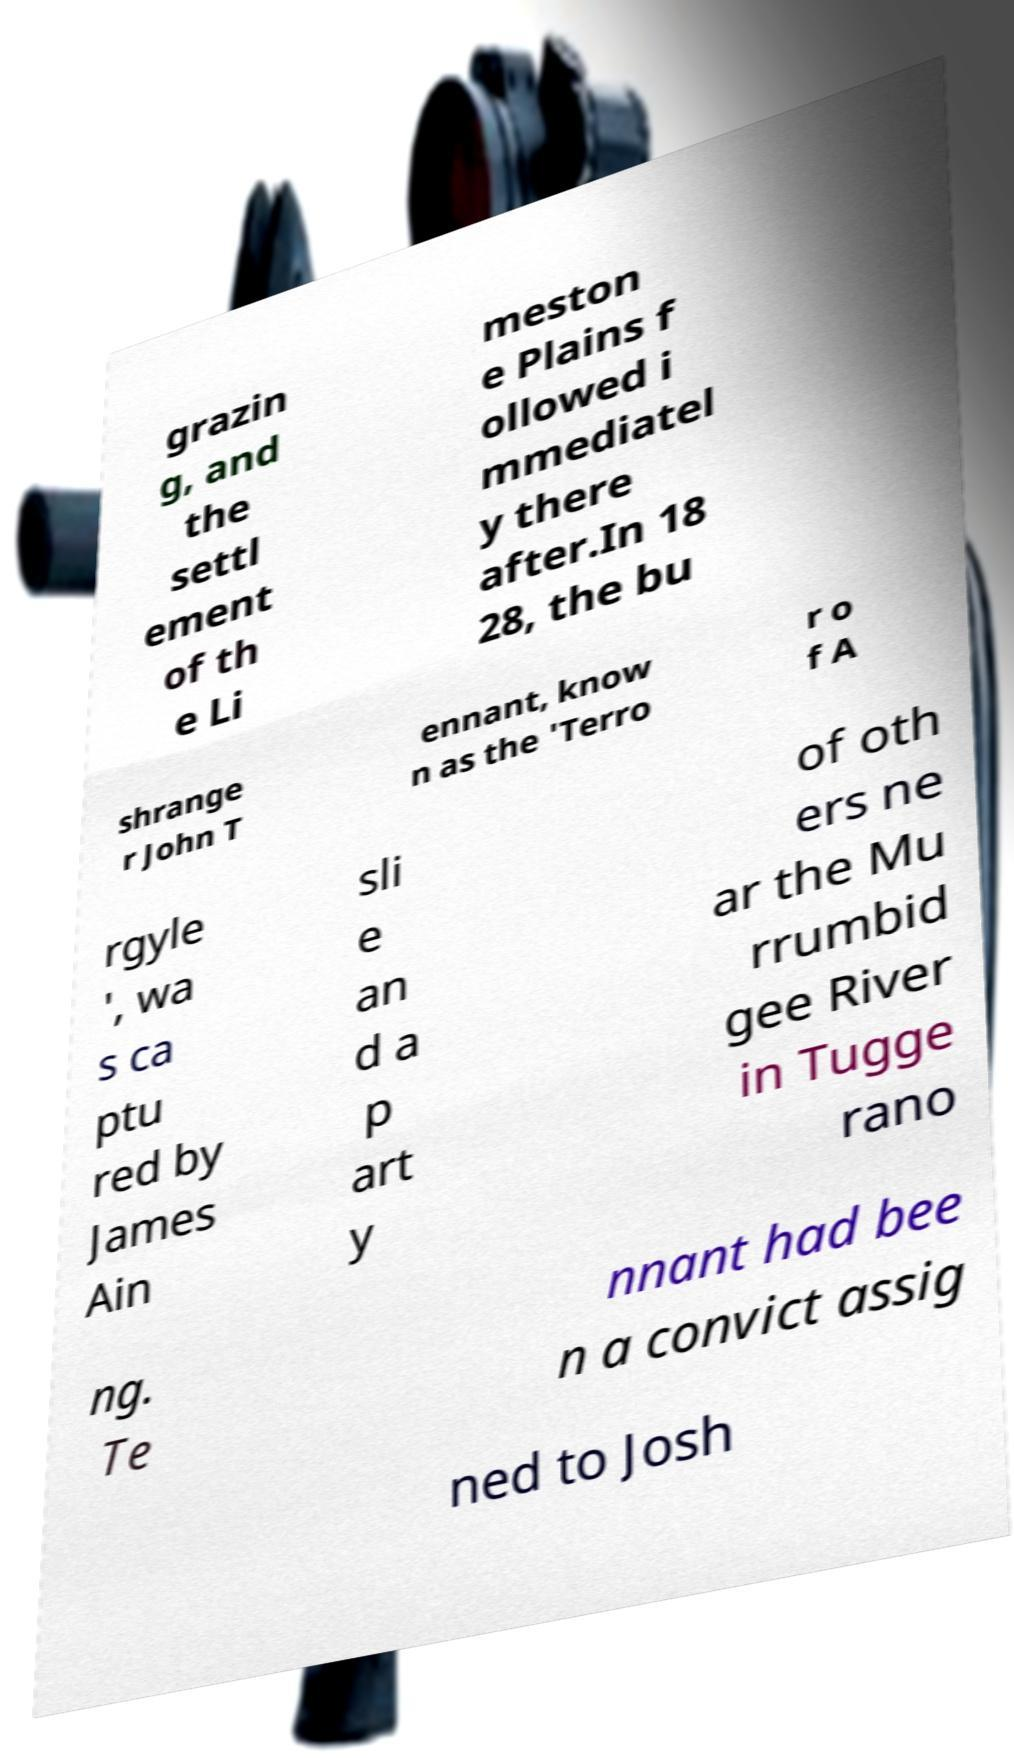Please identify and transcribe the text found in this image. grazin g, and the settl ement of th e Li meston e Plains f ollowed i mmediatel y there after.In 18 28, the bu shrange r John T ennant, know n as the 'Terro r o f A rgyle ', wa s ca ptu red by James Ain sli e an d a p art y of oth ers ne ar the Mu rrumbid gee River in Tugge rano ng. Te nnant had bee n a convict assig ned to Josh 